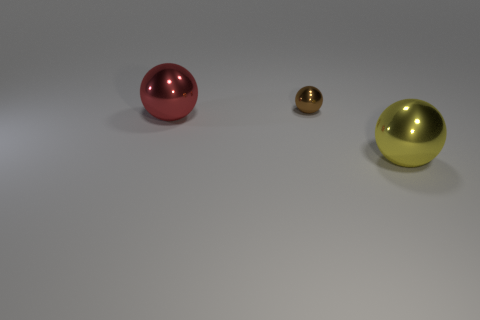Subtract all tiny brown spheres. How many spheres are left? 2 Subtract all yellow spheres. How many spheres are left? 2 Subtract 1 spheres. How many spheres are left? 2 Add 1 brown balls. How many objects exist? 4 Subtract 0 brown cylinders. How many objects are left? 3 Subtract all yellow spheres. Subtract all brown cylinders. How many spheres are left? 2 Subtract all large matte cylinders. Subtract all yellow objects. How many objects are left? 2 Add 1 tiny metallic spheres. How many tiny metallic spheres are left? 2 Add 2 big cyan rubber blocks. How many big cyan rubber blocks exist? 2 